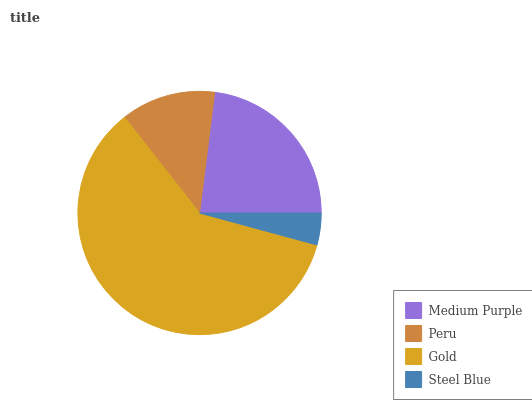Is Steel Blue the minimum?
Answer yes or no. Yes. Is Gold the maximum?
Answer yes or no. Yes. Is Peru the minimum?
Answer yes or no. No. Is Peru the maximum?
Answer yes or no. No. Is Medium Purple greater than Peru?
Answer yes or no. Yes. Is Peru less than Medium Purple?
Answer yes or no. Yes. Is Peru greater than Medium Purple?
Answer yes or no. No. Is Medium Purple less than Peru?
Answer yes or no. No. Is Medium Purple the high median?
Answer yes or no. Yes. Is Peru the low median?
Answer yes or no. Yes. Is Peru the high median?
Answer yes or no. No. Is Steel Blue the low median?
Answer yes or no. No. 